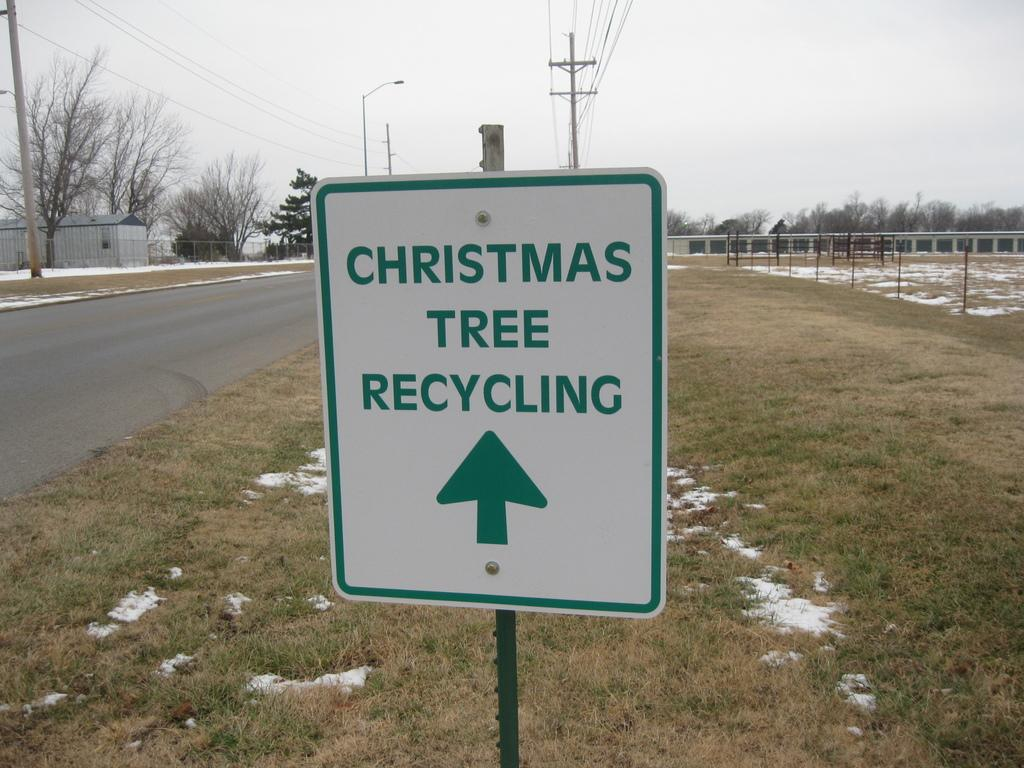<image>
Present a compact description of the photo's key features. A sign points drivers to the Christmas Tree recycling location. 